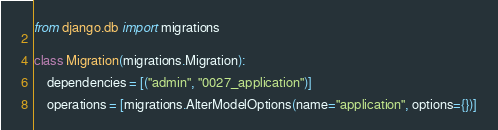Convert code to text. <code><loc_0><loc_0><loc_500><loc_500><_Python_>
from django.db import migrations


class Migration(migrations.Migration):

    dependencies = [("admin", "0027_application")]

    operations = [migrations.AlterModelOptions(name="application", options={})]
</code> 